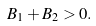<formula> <loc_0><loc_0><loc_500><loc_500>B _ { 1 } + B _ { 2 } > 0 .</formula> 